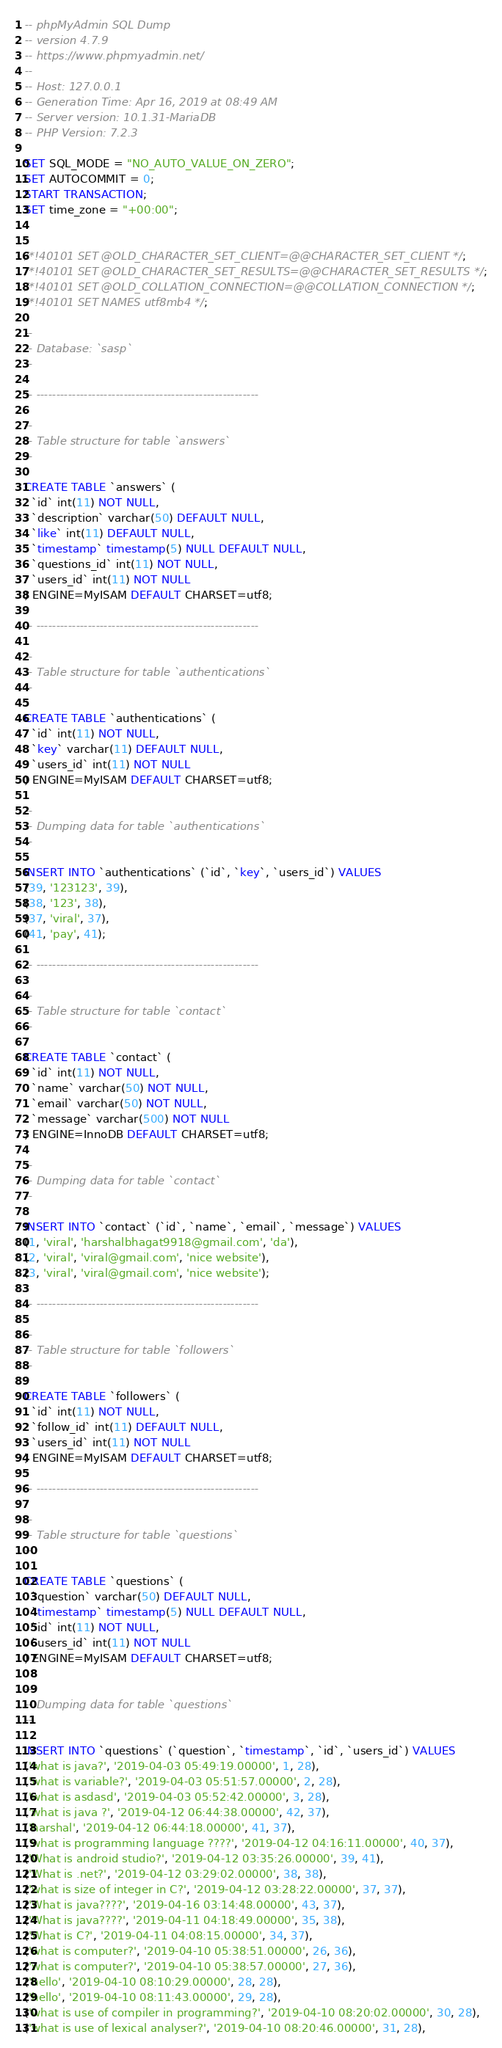<code> <loc_0><loc_0><loc_500><loc_500><_SQL_>-- phpMyAdmin SQL Dump
-- version 4.7.9
-- https://www.phpmyadmin.net/
--
-- Host: 127.0.0.1
-- Generation Time: Apr 16, 2019 at 08:49 AM
-- Server version: 10.1.31-MariaDB
-- PHP Version: 7.2.3

SET SQL_MODE = "NO_AUTO_VALUE_ON_ZERO";
SET AUTOCOMMIT = 0;
START TRANSACTION;
SET time_zone = "+00:00";


/*!40101 SET @OLD_CHARACTER_SET_CLIENT=@@CHARACTER_SET_CLIENT */;
/*!40101 SET @OLD_CHARACTER_SET_RESULTS=@@CHARACTER_SET_RESULTS */;
/*!40101 SET @OLD_COLLATION_CONNECTION=@@COLLATION_CONNECTION */;
/*!40101 SET NAMES utf8mb4 */;

--
-- Database: `sasp`
--

-- --------------------------------------------------------

--
-- Table structure for table `answers`
--

CREATE TABLE `answers` (
  `id` int(11) NOT NULL,
  `description` varchar(50) DEFAULT NULL,
  `like` int(11) DEFAULT NULL,
  `timestamp` timestamp(5) NULL DEFAULT NULL,
  `questions_id` int(11) NOT NULL,
  `users_id` int(11) NOT NULL
) ENGINE=MyISAM DEFAULT CHARSET=utf8;

-- --------------------------------------------------------

--
-- Table structure for table `authentications`
--

CREATE TABLE `authentications` (
  `id` int(11) NOT NULL,
  `key` varchar(11) DEFAULT NULL,
  `users_id` int(11) NOT NULL
) ENGINE=MyISAM DEFAULT CHARSET=utf8;

--
-- Dumping data for table `authentications`
--

INSERT INTO `authentications` (`id`, `key`, `users_id`) VALUES
(39, '123123', 39),
(38, '123', 38),
(37, 'viral', 37),
(41, 'pay', 41);

-- --------------------------------------------------------

--
-- Table structure for table `contact`
--

CREATE TABLE `contact` (
  `id` int(11) NOT NULL,
  `name` varchar(50) NOT NULL,
  `email` varchar(50) NOT NULL,
  `message` varchar(500) NOT NULL
) ENGINE=InnoDB DEFAULT CHARSET=utf8;

--
-- Dumping data for table `contact`
--

INSERT INTO `contact` (`id`, `name`, `email`, `message`) VALUES
(1, 'viral', 'harshalbhagat9918@gmail.com', 'da'),
(2, 'viral', 'viral@gmail.com', 'nice website'),
(3, 'viral', 'viral@gmail.com', 'nice website');

-- --------------------------------------------------------

--
-- Table structure for table `followers`
--

CREATE TABLE `followers` (
  `id` int(11) NOT NULL,
  `follow_id` int(11) DEFAULT NULL,
  `users_id` int(11) NOT NULL
) ENGINE=MyISAM DEFAULT CHARSET=utf8;

-- --------------------------------------------------------

--
-- Table structure for table `questions`
--

CREATE TABLE `questions` (
  `question` varchar(50) DEFAULT NULL,
  `timestamp` timestamp(5) NULL DEFAULT NULL,
  `id` int(11) NOT NULL,
  `users_id` int(11) NOT NULL
) ENGINE=MyISAM DEFAULT CHARSET=utf8;

--
-- Dumping data for table `questions`
--

INSERT INTO `questions` (`question`, `timestamp`, `id`, `users_id`) VALUES
('what is java?', '2019-04-03 05:49:19.00000', 1, 28),
('what is variable?', '2019-04-03 05:51:57.00000', 2, 28),
('what is asdasd', '2019-04-03 05:52:42.00000', 3, 28),
('what is java ?', '2019-04-12 06:44:38.00000', 42, 37),
('harshal', '2019-04-12 06:44:18.00000', 41, 37),
('what is programming language ????', '2019-04-12 04:16:11.00000', 40, 37),
('What is android studio?', '2019-04-12 03:35:26.00000', 39, 41),
('What is .net?', '2019-04-12 03:29:02.00000', 38, 38),
('what is size of integer in C?', '2019-04-12 03:28:22.00000', 37, 37),
('What is java????', '2019-04-16 03:14:48.00000', 43, 37),
('What is java????', '2019-04-11 04:18:49.00000', 35, 38),
('What is C?', '2019-04-11 04:08:15.00000', 34, 37),
('what is computer?', '2019-04-10 05:38:51.00000', 26, 36),
('what is computer?', '2019-04-10 05:38:57.00000', 27, 36),
('hello', '2019-04-10 08:10:29.00000', 28, 28),
('hello', '2019-04-10 08:11:43.00000', 29, 28),
('what is use of compiler in programming?', '2019-04-10 08:20:02.00000', 30, 28),
('what is use of lexical analyser?', '2019-04-10 08:20:46.00000', 31, 28),</code> 